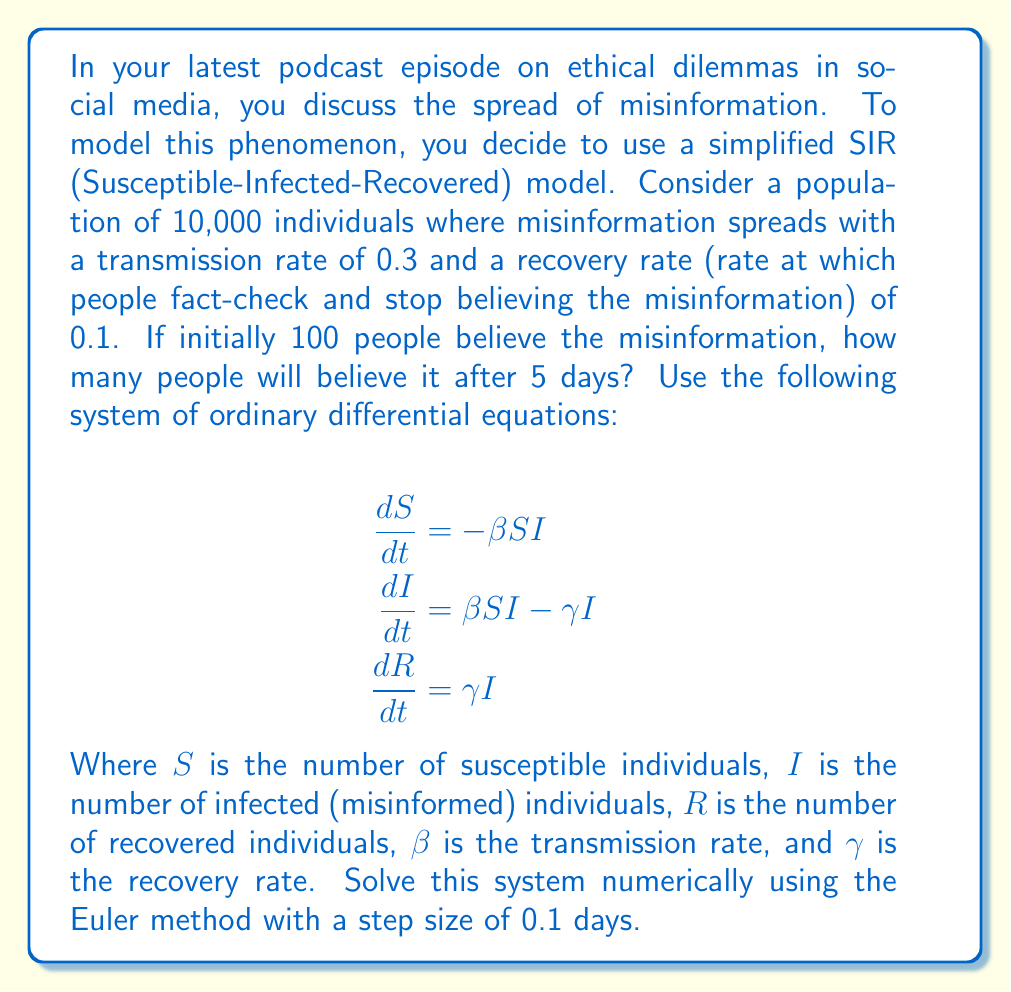What is the answer to this math problem? To solve this problem, we'll use the Euler method to numerically approximate the solution to the system of ordinary differential equations. We'll proceed step by step:

1. Initialize the variables:
   $S_0 = 9900$, $I_0 = 100$, $R_0 = 0$
   $\beta = 0.3$, $\gamma = 0.1$
   $\Delta t = 0.1$ (step size)
   $T = 5$ (total time)

2. Set up the Euler method equations:
   $$\begin{align}
   S_{n+1} &= S_n + \Delta t \cdot (-\beta S_n I_n) \\
   I_{n+1} &= I_n + \Delta t \cdot (\beta S_n I_n - \gamma I_n) \\
   R_{n+1} &= R_n + \Delta t \cdot (\gamma I_n)
   \end{align}$$

3. Implement the Euler method:
   We need to iterate 50 times (5 days / 0.1 step size = 50 steps)

   Here's a table showing the first few iterations and the final result:

   | Step | Time | S      | I      | R      |
   |------|------|--------|--------|--------|
   | 0    | 0.0  | 9900.0 | 100.0  | 0.0    |
   | 1    | 0.1  | 9870.3 | 129.0  | 0.7    |
   | 2    | 0.2  | 9833.1 | 165.0  | 1.9    |
   | ...  | ...  | ...    | ...    | ...    |
   | 50   | 5.0  | 5260.8 | 4019.2 | 720.0  |

4. After 5 days (50 iterations), we find that approximately 4019 people believe the misinformation.

Note: The Euler method is a simple numerical method and may not be as accurate as more sophisticated methods like Runge-Kutta. However, it provides a good approximation for this problem.
Answer: After 5 days, approximately 4019 people will believe the misinformation. 